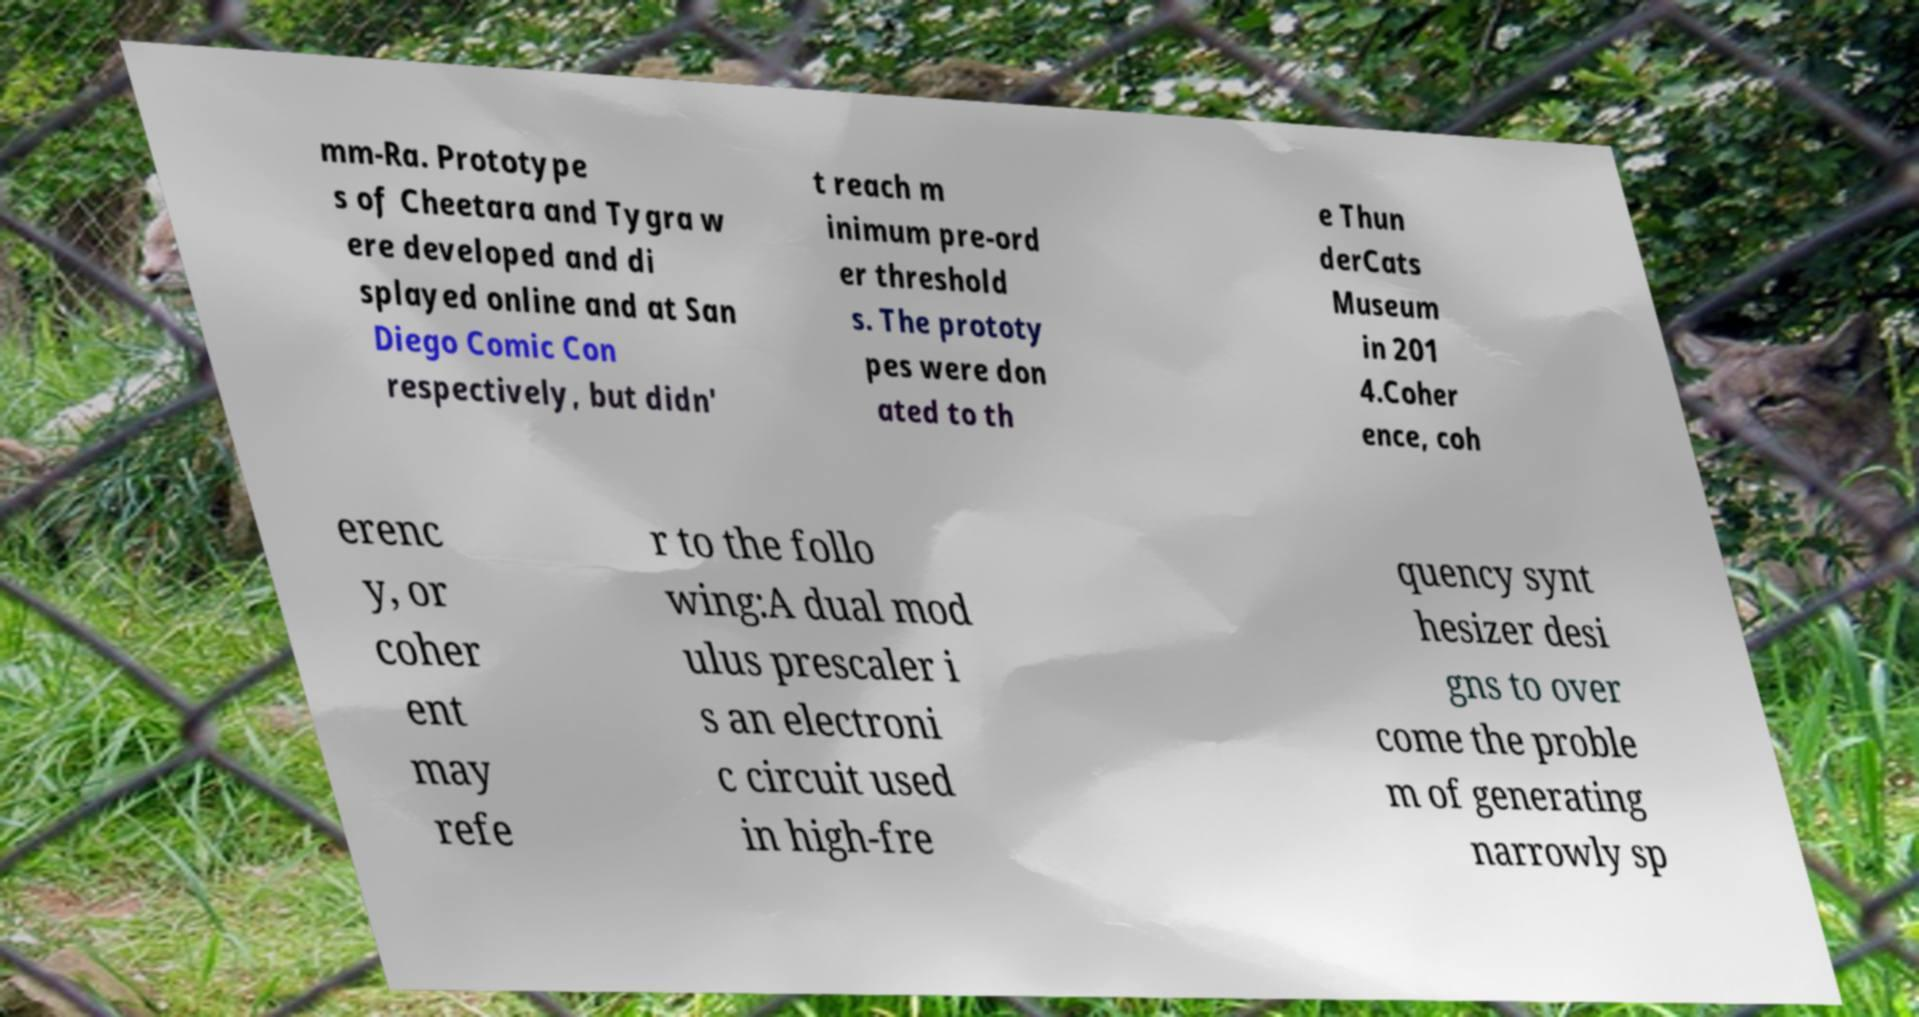Can you read and provide the text displayed in the image?This photo seems to have some interesting text. Can you extract and type it out for me? mm-Ra. Prototype s of Cheetara and Tygra w ere developed and di splayed online and at San Diego Comic Con respectively, but didn' t reach m inimum pre-ord er threshold s. The prototy pes were don ated to th e Thun derCats Museum in 201 4.Coher ence, coh erenc y, or coher ent may refe r to the follo wing:A dual mod ulus prescaler i s an electroni c circuit used in high-fre quency synt hesizer desi gns to over come the proble m of generating narrowly sp 